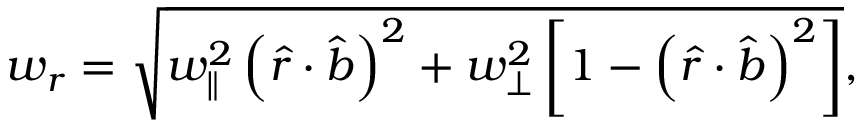Convert formula to latex. <formula><loc_0><loc_0><loc_500><loc_500>w _ { r } = \sqrt { w _ { \| } ^ { 2 } \left ( \hat { r } \cdot \hat { b } \right ) ^ { 2 } + w _ { \perp } ^ { 2 } \left [ 1 - \left ( \hat { r } \cdot \hat { b } \right ) ^ { 2 } \right ] } ,</formula> 